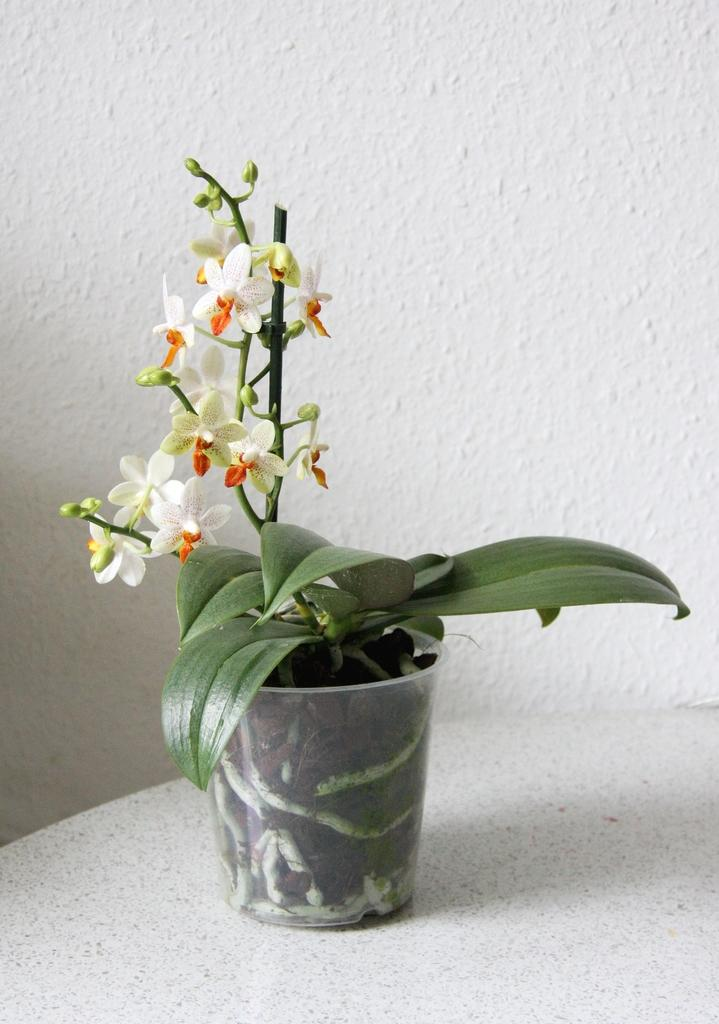What type of plant is in the image? There is a house plant in the image. Where is the house plant located? The house plant is placed on a table. What can be seen in the background of the image? There is a wall in the background of the image. How does the house plant contribute to the idea of setting up a tent in the image? The image does not depict a tent or any activity related to setting up a tent, so the house plant's contribution to that idea cannot be determined. 